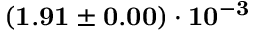Convert formula to latex. <formula><loc_0><loc_0><loc_500><loc_500>( 1 . 9 1 \pm 0 . 0 0 ) \cdot 1 0 ^ { - 3 }</formula> 